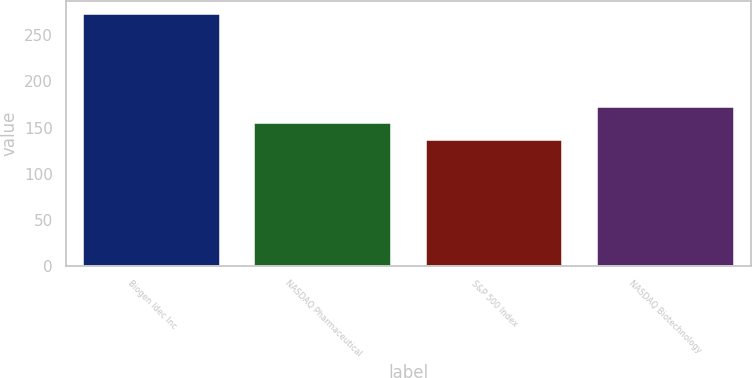<chart> <loc_0><loc_0><loc_500><loc_500><bar_chart><fcel>Biogen Idec Inc<fcel>NASDAQ Pharmaceutical<fcel>S&P 500 Index<fcel>NASDAQ Biotechnology<nl><fcel>273.59<fcel>154.38<fcel>136.3<fcel>172.67<nl></chart> 